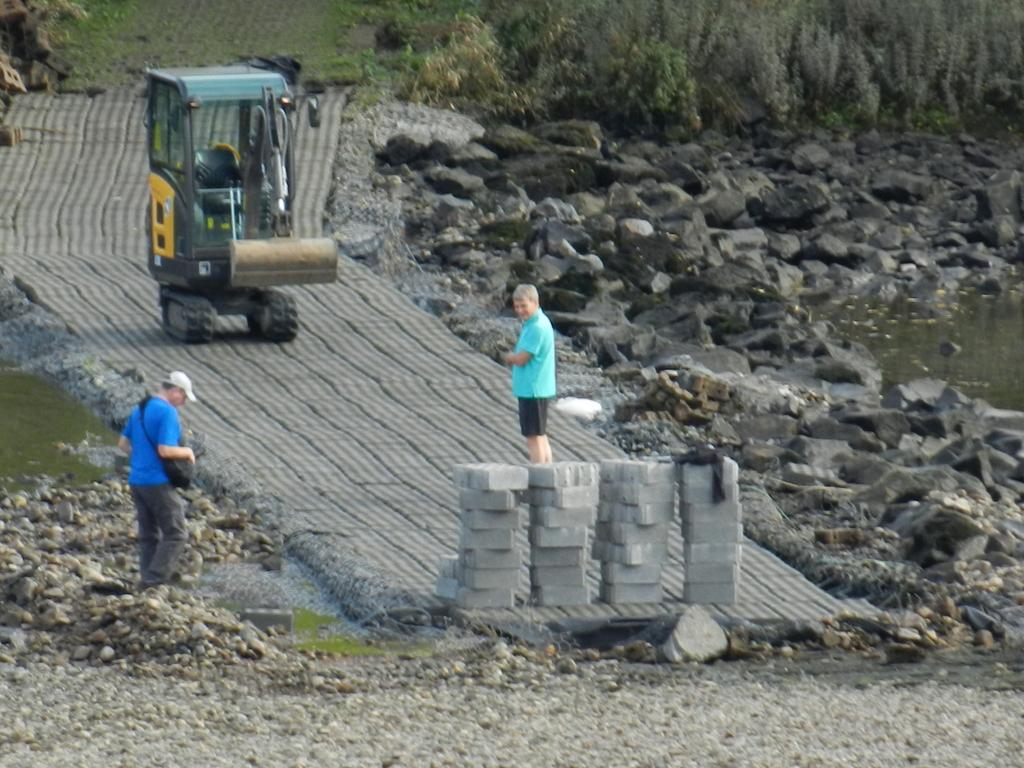What is the main subject of the image? The main subject of the image is people standing on an under-construction road. What type of material can be seen in the image? There are bricks visible in the image. What else can be seen in the image besides the people and bricks? There are other unspecified objects present in the image. What type of window treatment is visible in the image? There is no window or window treatment present in the image; it features people standing on an under-construction road with bricks and other unspecified objects. What type of linen is being used to clean the bricks in the image? There is no linen or cleaning activity visible in the image; it simply shows people standing on an under-construction road with bricks and other unspecified objects. 